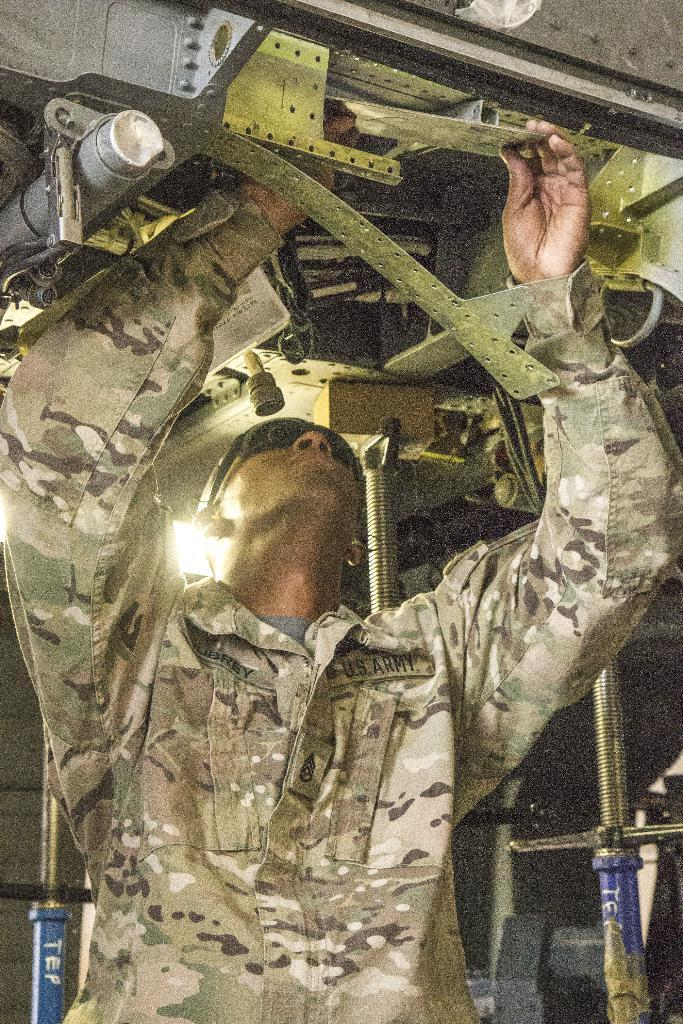Who is present in the image? There is a man in the image. What is the man wearing? The man is wearing a uniform. Where is the man positioned in relation to the picture? The man is standing in front of the picture. What is the man doing in the image? The man is repairing something. What type of equipment can be seen at the top of the picture? There is electrical equipment at the top of the picture. What does the man's father say about his feet in the image? There is no mention of the man's father or his feet in the image. 